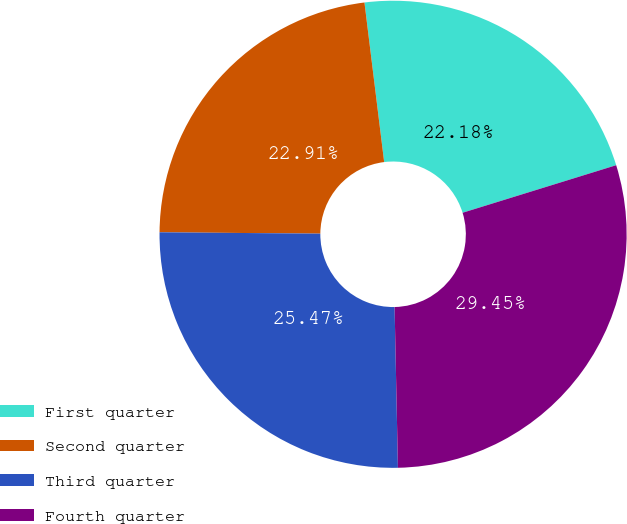Convert chart. <chart><loc_0><loc_0><loc_500><loc_500><pie_chart><fcel>First quarter<fcel>Second quarter<fcel>Third quarter<fcel>Fourth quarter<nl><fcel>22.18%<fcel>22.91%<fcel>25.47%<fcel>29.45%<nl></chart> 